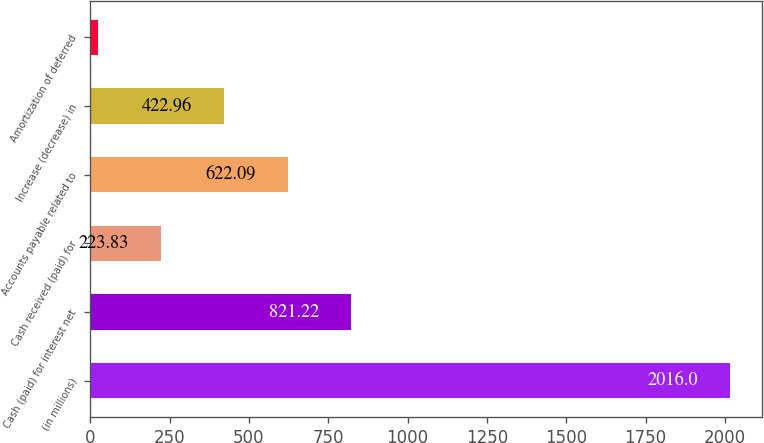Convert chart to OTSL. <chart><loc_0><loc_0><loc_500><loc_500><bar_chart><fcel>(in millions)<fcel>Cash (paid) for interest net<fcel>Cash received (paid) for<fcel>Accounts payable related to<fcel>Increase (decrease) in<fcel>Amortization of deferred<nl><fcel>2016<fcel>821.22<fcel>223.83<fcel>622.09<fcel>422.96<fcel>24.7<nl></chart> 